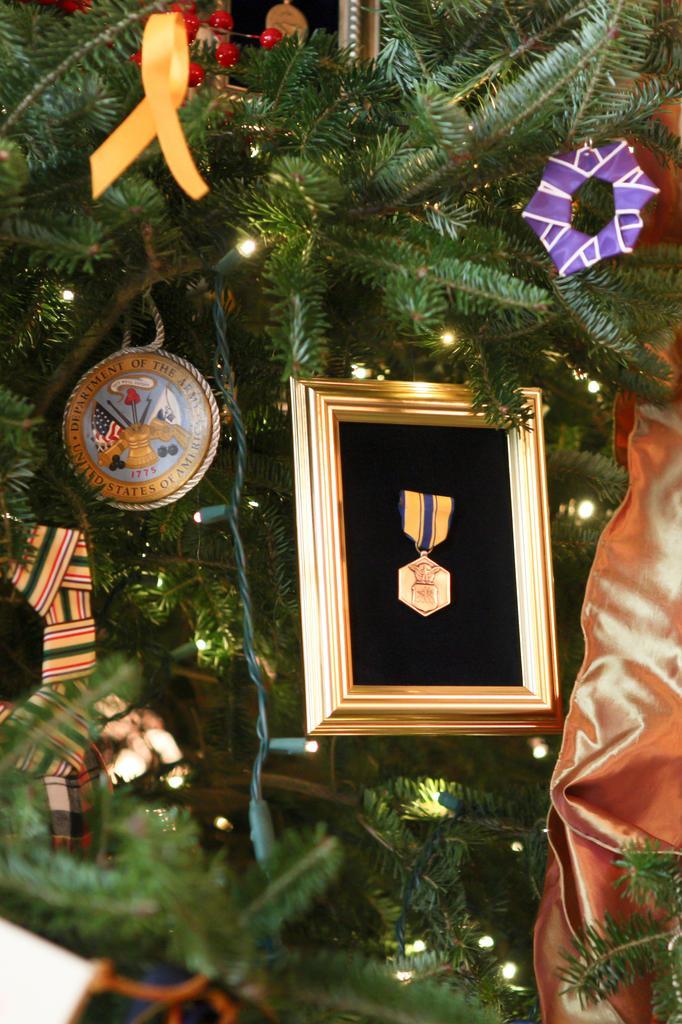Could you give a brief overview of what you see in this image? In this image I can see a Christmas tree and I can see few decorative items. In front I can see a frame, background I can see few lights. 